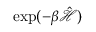Convert formula to latex. <formula><loc_0><loc_0><loc_500><loc_500>\exp ( - \beta \hat { \mathcal { H } } )</formula> 